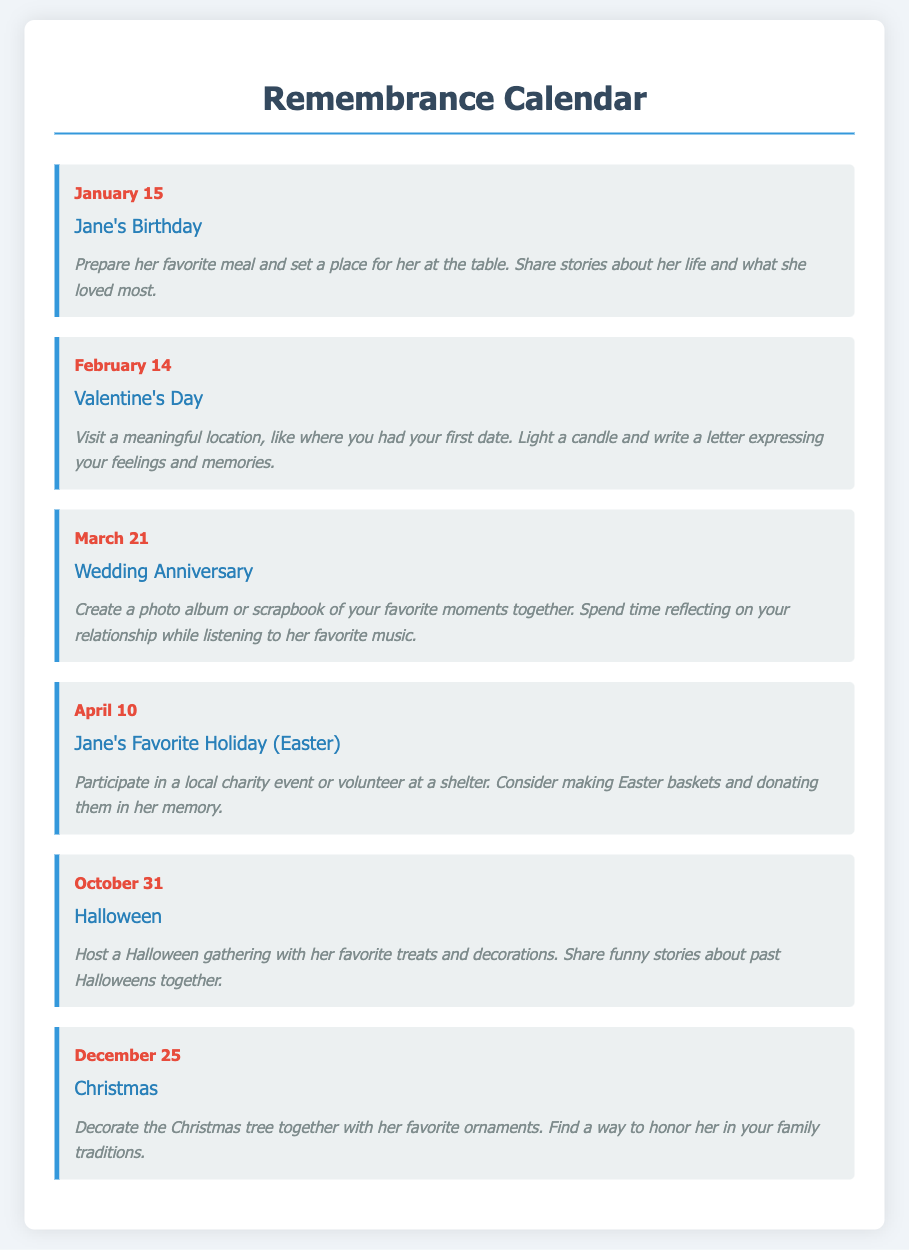What is the date of Jane's birthday? The document lists January 15 as the date of Jane's birthday.
Answer: January 15 What is suggested for Valentine's Day? The document suggests visiting a meaningful location and writing a letter expressing feelings and memories on Valentine's Day.
Answer: Visit a meaningful location and write a letter What activity is suggested for April 10? The event on April 10 suggests participating in a local charity event or volunteering at a shelter.
Answer: Participate in a local charity event or volunteer How many significant dates are listed in the document? There are six events listed in the remembrance calendar document.
Answer: Six What is the theme of the suggested activity for Christmas? The suggested activity for Christmas is about decorating the Christmas tree and honoring her in family traditions.
Answer: Decorating the Christmas tree and honoring her What month is the Wedding Anniversary celebrated? The Wedding Anniversary is celebrated in March according to the document.
Answer: March What type of event is October 31? October 31 is identified as Halloween in the remembrance calendar.
Answer: Halloween What is one suggestion for Jane's Birthday remembrance activity? One suggestion is to prepare her favorite meal and share stories about her life on her birthday.
Answer: Prepare her favorite meal and share stories 